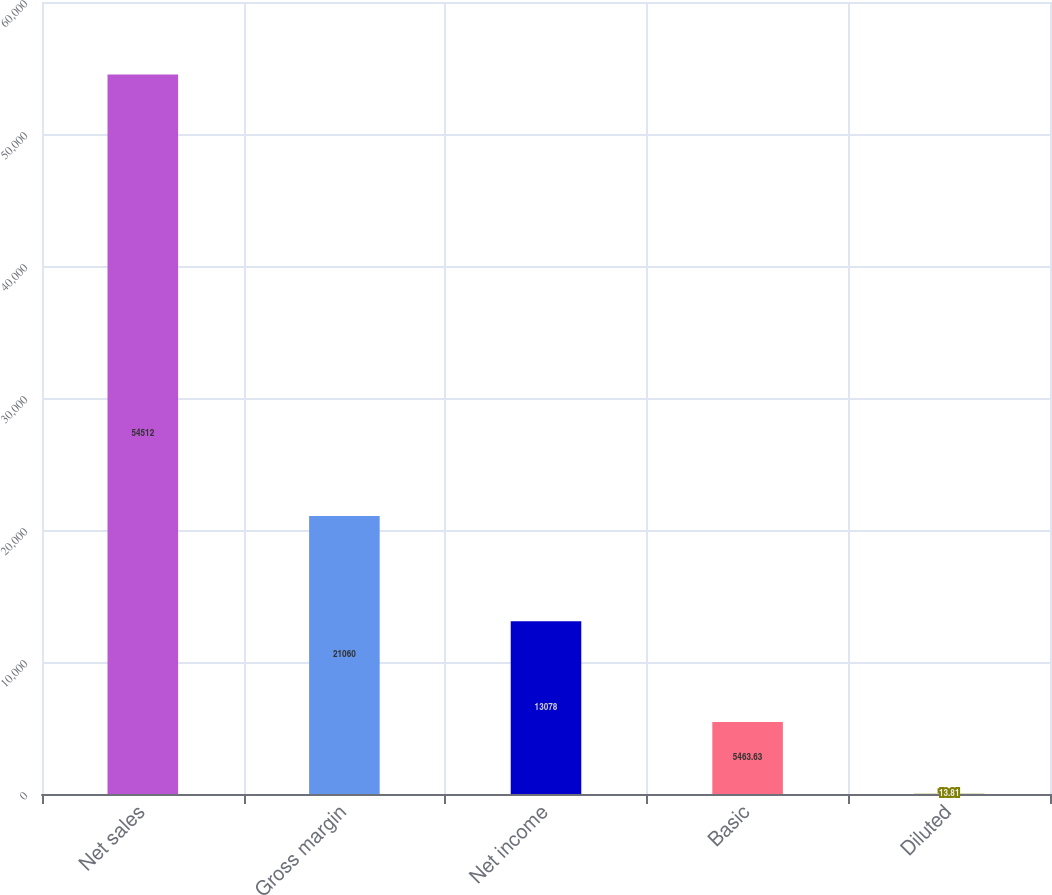Convert chart. <chart><loc_0><loc_0><loc_500><loc_500><bar_chart><fcel>Net sales<fcel>Gross margin<fcel>Net income<fcel>Basic<fcel>Diluted<nl><fcel>54512<fcel>21060<fcel>13078<fcel>5463.63<fcel>13.81<nl></chart> 